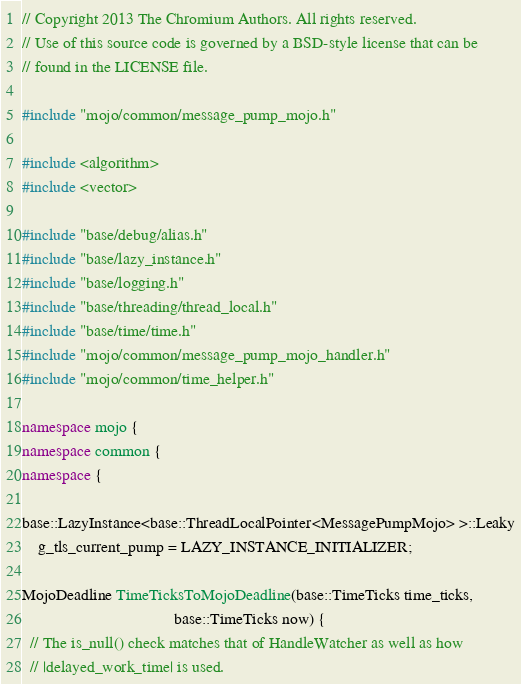Convert code to text. <code><loc_0><loc_0><loc_500><loc_500><_C++_>// Copyright 2013 The Chromium Authors. All rights reserved.
// Use of this source code is governed by a BSD-style license that can be
// found in the LICENSE file.

#include "mojo/common/message_pump_mojo.h"

#include <algorithm>
#include <vector>

#include "base/debug/alias.h"
#include "base/lazy_instance.h"
#include "base/logging.h"
#include "base/threading/thread_local.h"
#include "base/time/time.h"
#include "mojo/common/message_pump_mojo_handler.h"
#include "mojo/common/time_helper.h"

namespace mojo {
namespace common {
namespace {

base::LazyInstance<base::ThreadLocalPointer<MessagePumpMojo> >::Leaky
    g_tls_current_pump = LAZY_INSTANCE_INITIALIZER;

MojoDeadline TimeTicksToMojoDeadline(base::TimeTicks time_ticks,
                                     base::TimeTicks now) {
  // The is_null() check matches that of HandleWatcher as well as how
  // |delayed_work_time| is used.</code> 